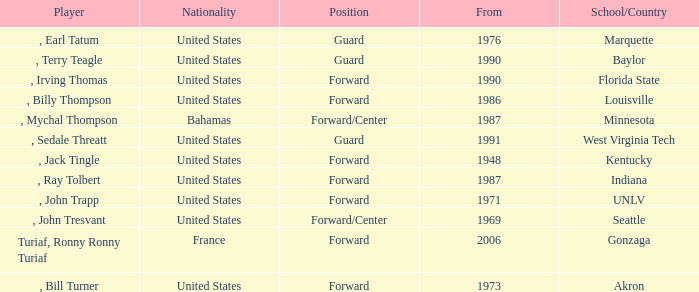What was the nationality of every player that attended Baylor? United States. 